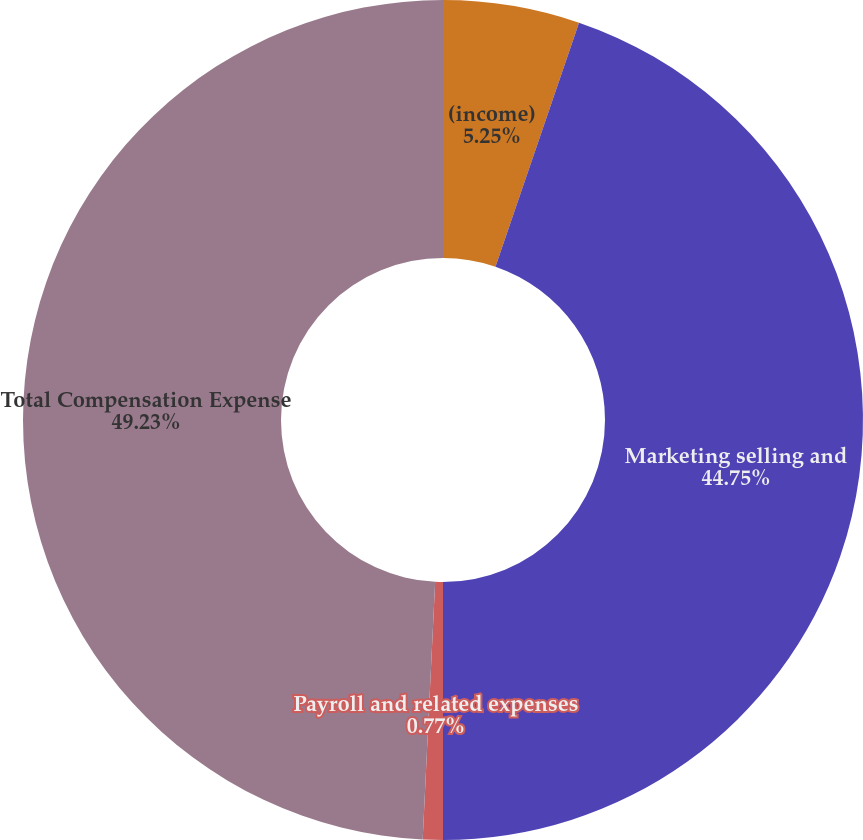Convert chart to OTSL. <chart><loc_0><loc_0><loc_500><loc_500><pie_chart><fcel>(income)<fcel>Marketing selling and<fcel>Payroll and related expenses<fcel>Total Compensation Expense<nl><fcel>5.25%<fcel>44.75%<fcel>0.77%<fcel>49.23%<nl></chart> 